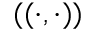<formula> <loc_0><loc_0><loc_500><loc_500>( ( \cdot , \cdot ) )</formula> 